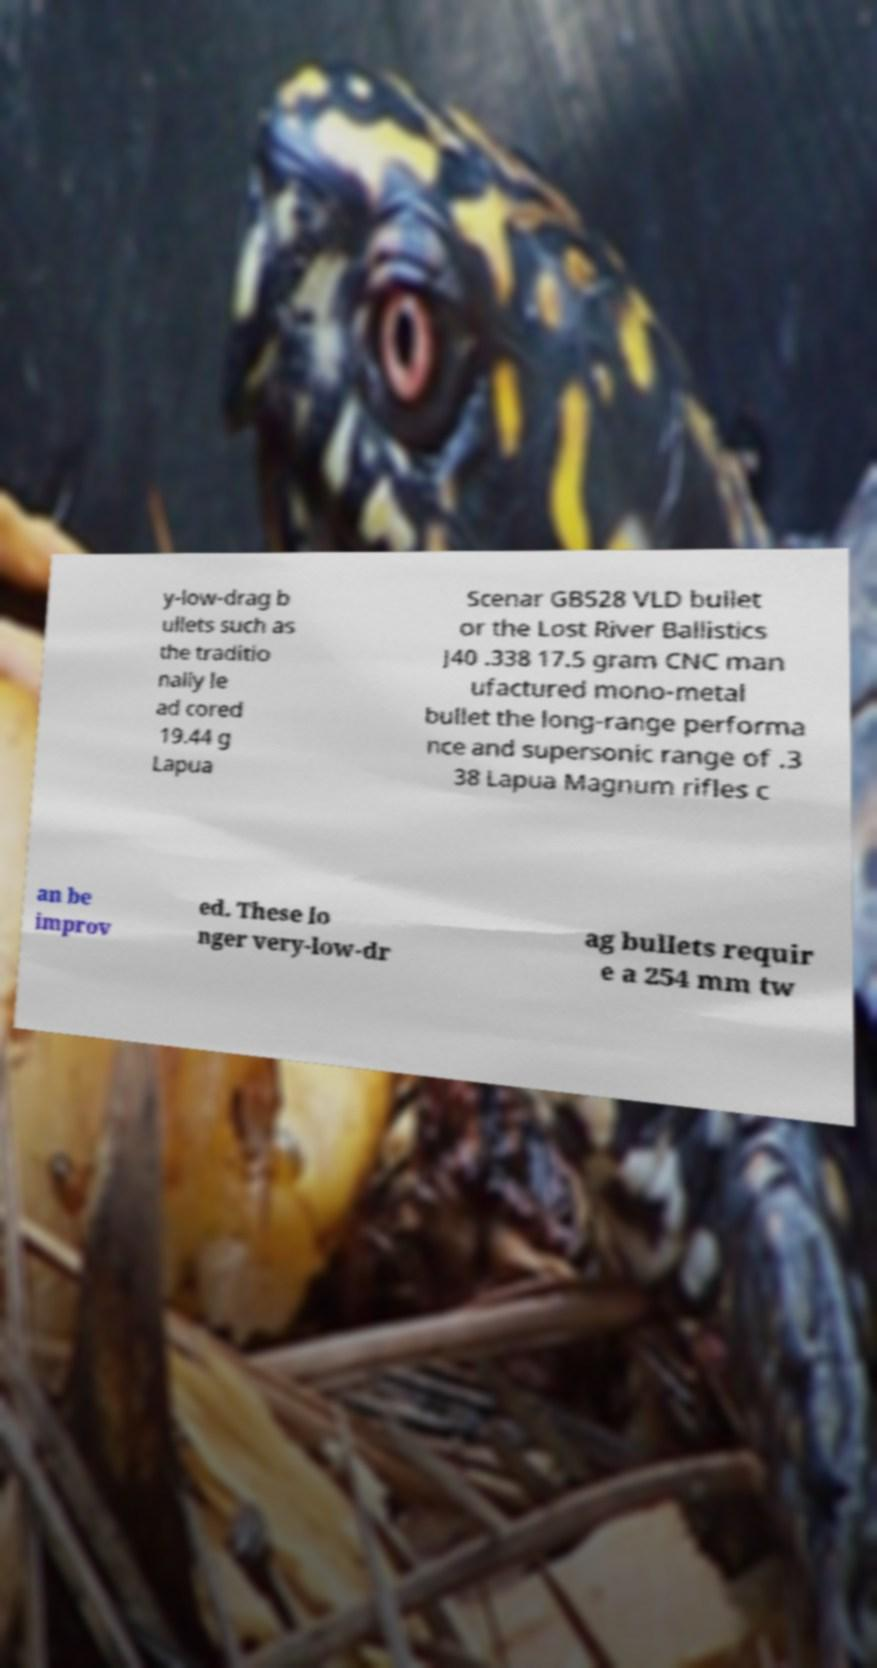What messages or text are displayed in this image? I need them in a readable, typed format. y-low-drag b ullets such as the traditio nally le ad cored 19.44 g Lapua Scenar GB528 VLD bullet or the Lost River Ballistics J40 .338 17.5 gram CNC man ufactured mono-metal bullet the long-range performa nce and supersonic range of .3 38 Lapua Magnum rifles c an be improv ed. These lo nger very-low-dr ag bullets requir e a 254 mm tw 